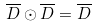<formula> <loc_0><loc_0><loc_500><loc_500>\overline { D } \odot \overline { D } = \overline { D }</formula> 